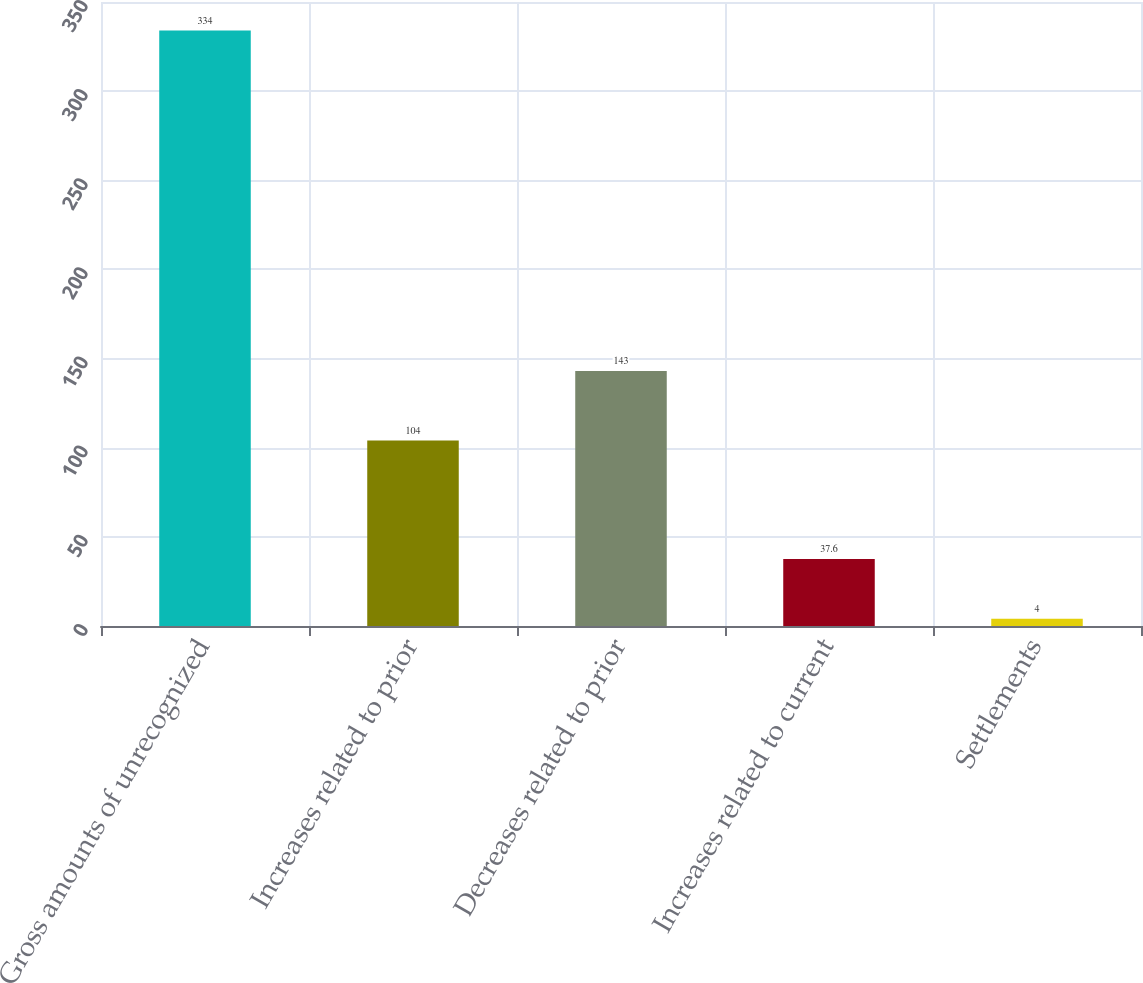Convert chart. <chart><loc_0><loc_0><loc_500><loc_500><bar_chart><fcel>Gross amounts of unrecognized<fcel>Increases related to prior<fcel>Decreases related to prior<fcel>Increases related to current<fcel>Settlements<nl><fcel>334<fcel>104<fcel>143<fcel>37.6<fcel>4<nl></chart> 